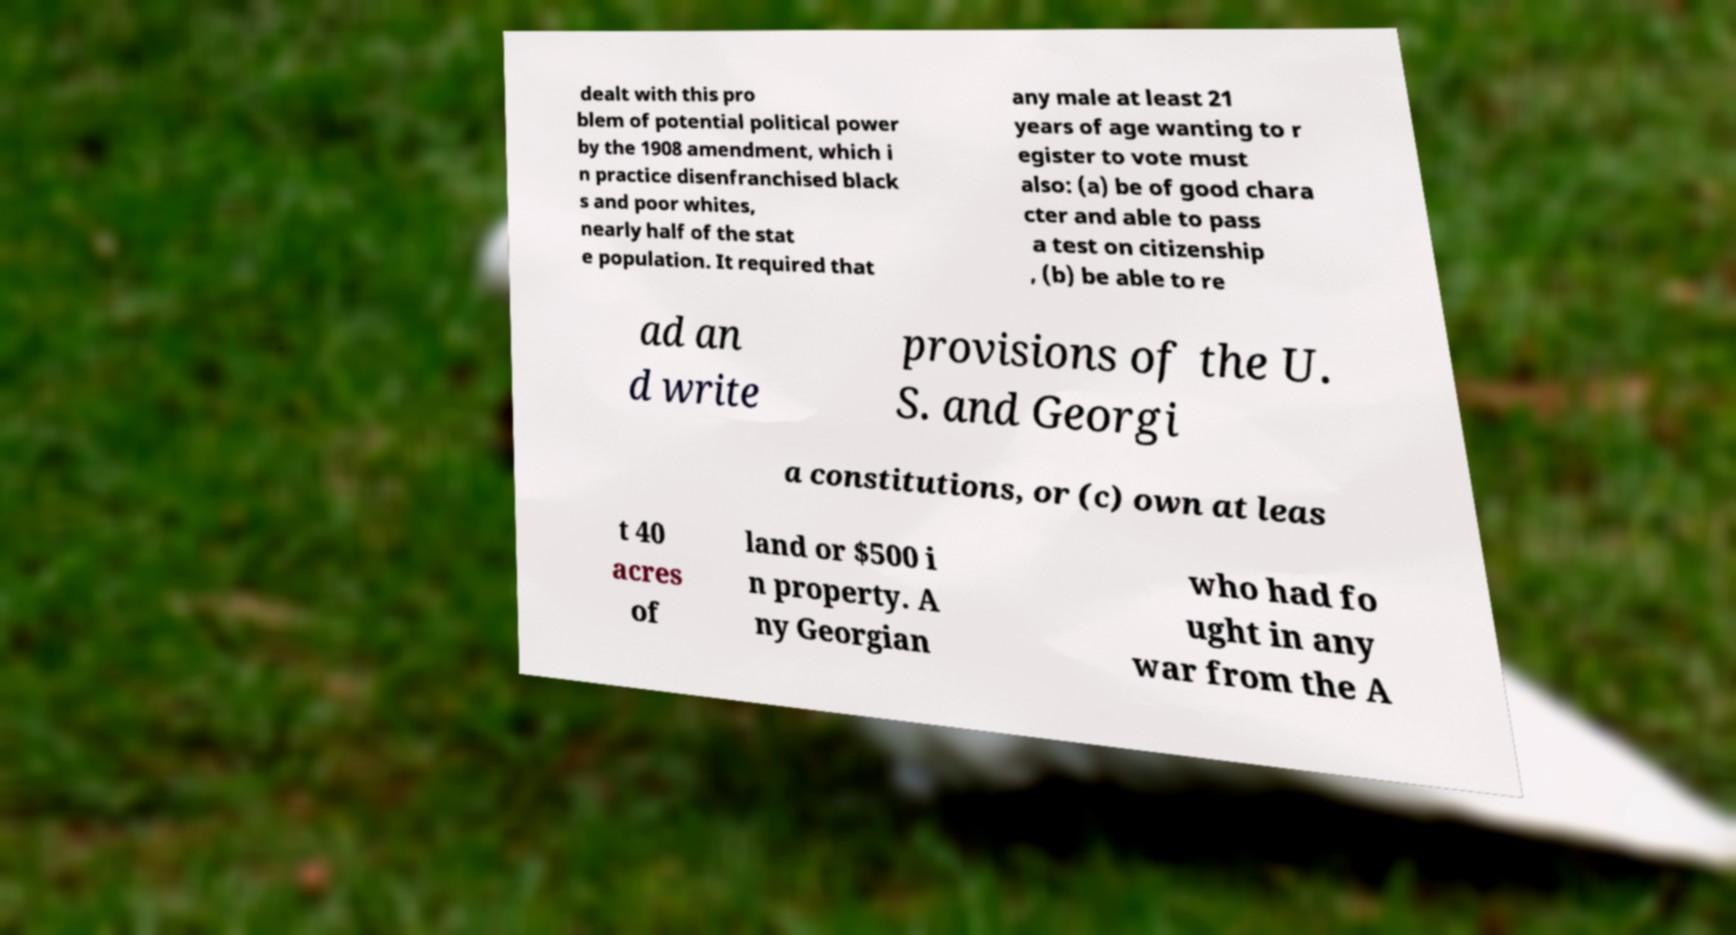For documentation purposes, I need the text within this image transcribed. Could you provide that? dealt with this pro blem of potential political power by the 1908 amendment, which i n practice disenfranchised black s and poor whites, nearly half of the stat e population. It required that any male at least 21 years of age wanting to r egister to vote must also: (a) be of good chara cter and able to pass a test on citizenship , (b) be able to re ad an d write provisions of the U. S. and Georgi a constitutions, or (c) own at leas t 40 acres of land or $500 i n property. A ny Georgian who had fo ught in any war from the A 